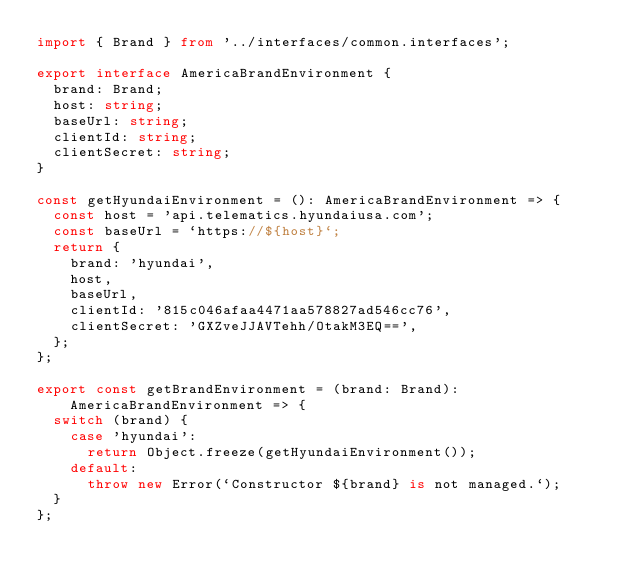<code> <loc_0><loc_0><loc_500><loc_500><_TypeScript_>import { Brand } from '../interfaces/common.interfaces';

export interface AmericaBrandEnvironment {
  brand: Brand;
  host: string;
  baseUrl: string;
  clientId: string;
  clientSecret: string;
}

const getHyundaiEnvironment = (): AmericaBrandEnvironment => {
  const host = 'api.telematics.hyundaiusa.com';
  const baseUrl = `https://${host}`;
  return {
    brand: 'hyundai',
    host,
    baseUrl,
    clientId: '815c046afaa4471aa578827ad546cc76',
    clientSecret: 'GXZveJJAVTehh/OtakM3EQ==',
  };
};

export const getBrandEnvironment = (brand: Brand): AmericaBrandEnvironment => {
  switch (brand) {
    case 'hyundai':
      return Object.freeze(getHyundaiEnvironment());
    default:
      throw new Error(`Constructor ${brand} is not managed.`);
  }
};
</code> 